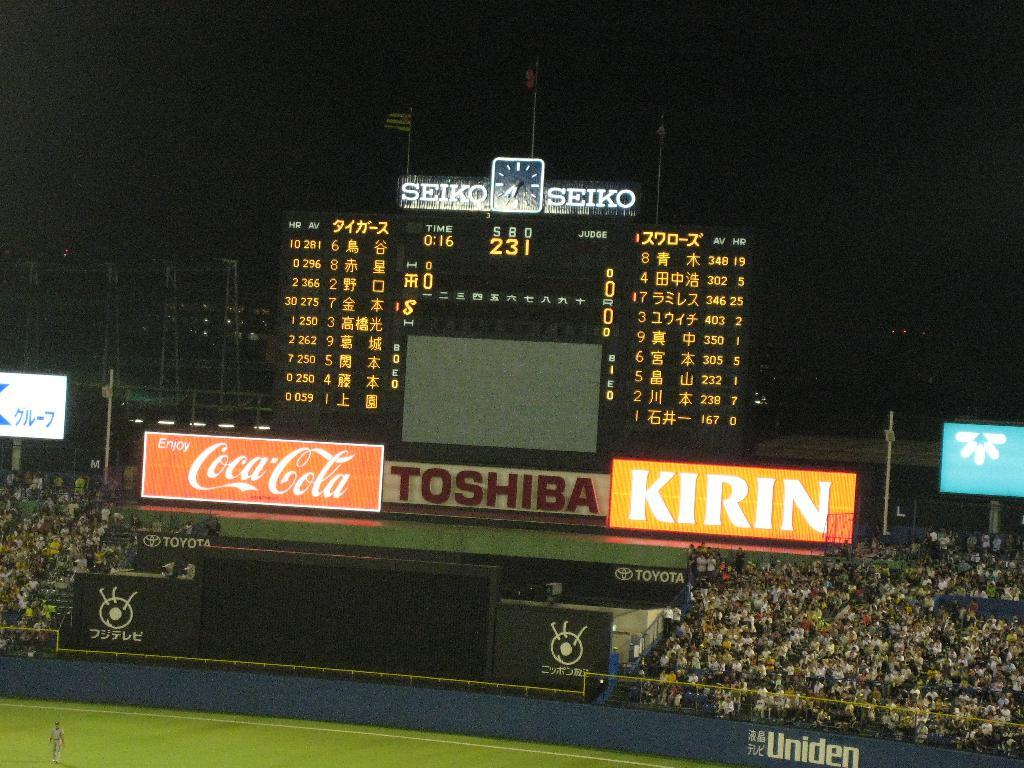<image>
Present a compact description of the photo's key features. The image features sponsorships from Toshiba and Kirin. 